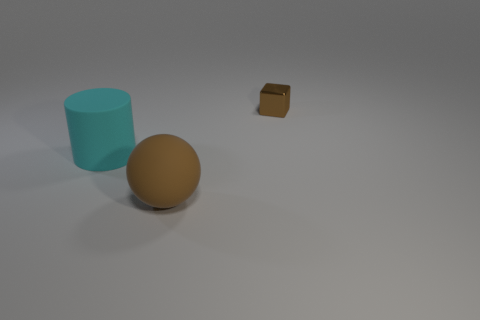Is there any other thing that is the same material as the small brown block?
Offer a very short reply. No. What number of other objects are there of the same size as the brown matte object?
Make the answer very short. 1. Are the small object and the brown object in front of the brown metal block made of the same material?
Your answer should be compact. No. What number of things are rubber objects that are in front of the cyan rubber object or brown things behind the cyan rubber cylinder?
Offer a very short reply. 2. What is the color of the large cylinder?
Give a very brief answer. Cyan. Is the number of big brown objects in front of the large brown thing less than the number of cubes?
Your answer should be very brief. Yes. Is there anything else that is the same shape as the brown matte thing?
Ensure brevity in your answer.  No. Is there a small blue metal cylinder?
Offer a very short reply. No. Are there fewer large brown matte things than big red blocks?
Offer a very short reply. No. What number of big purple objects have the same material as the cyan thing?
Ensure brevity in your answer.  0. 